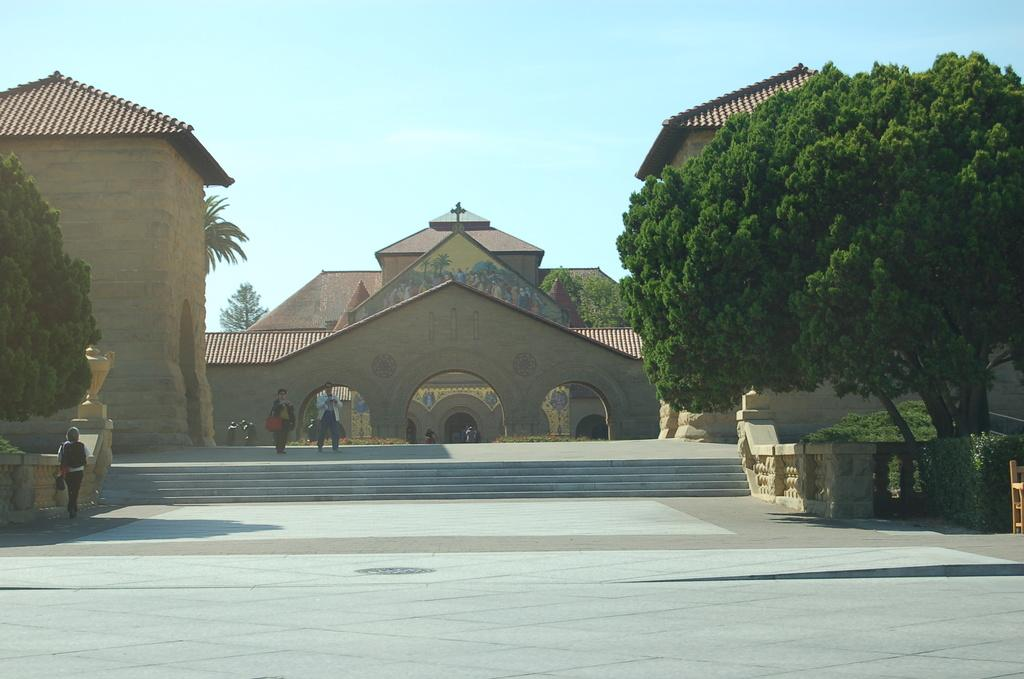How many people are in the image? There is a group of persons standing in the image. What can be seen in the background of the image? There is a building, a staircase, plants, trees, and the sky visible in the background of the image. What is the caption of the image? There is no caption provided with the image, so it cannot be determined. 